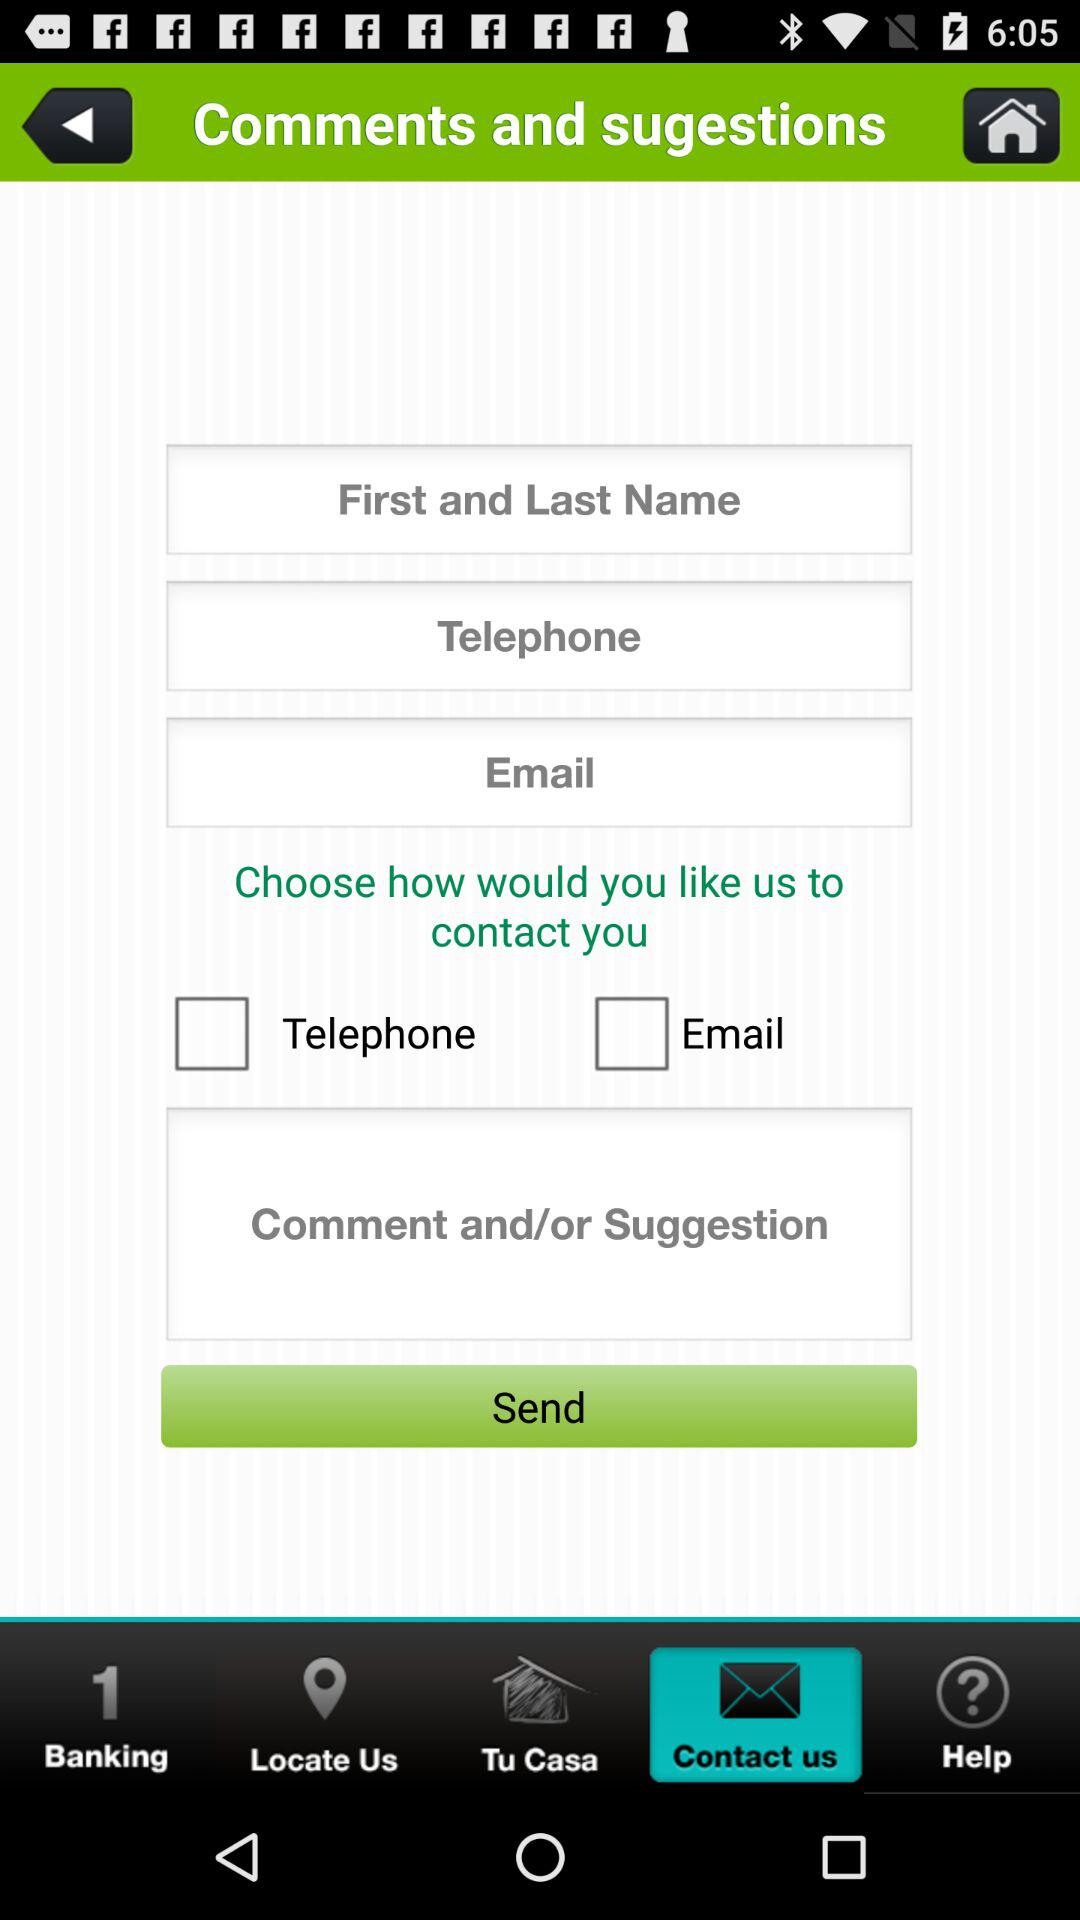What is the status of "Email"? The status is "off". 